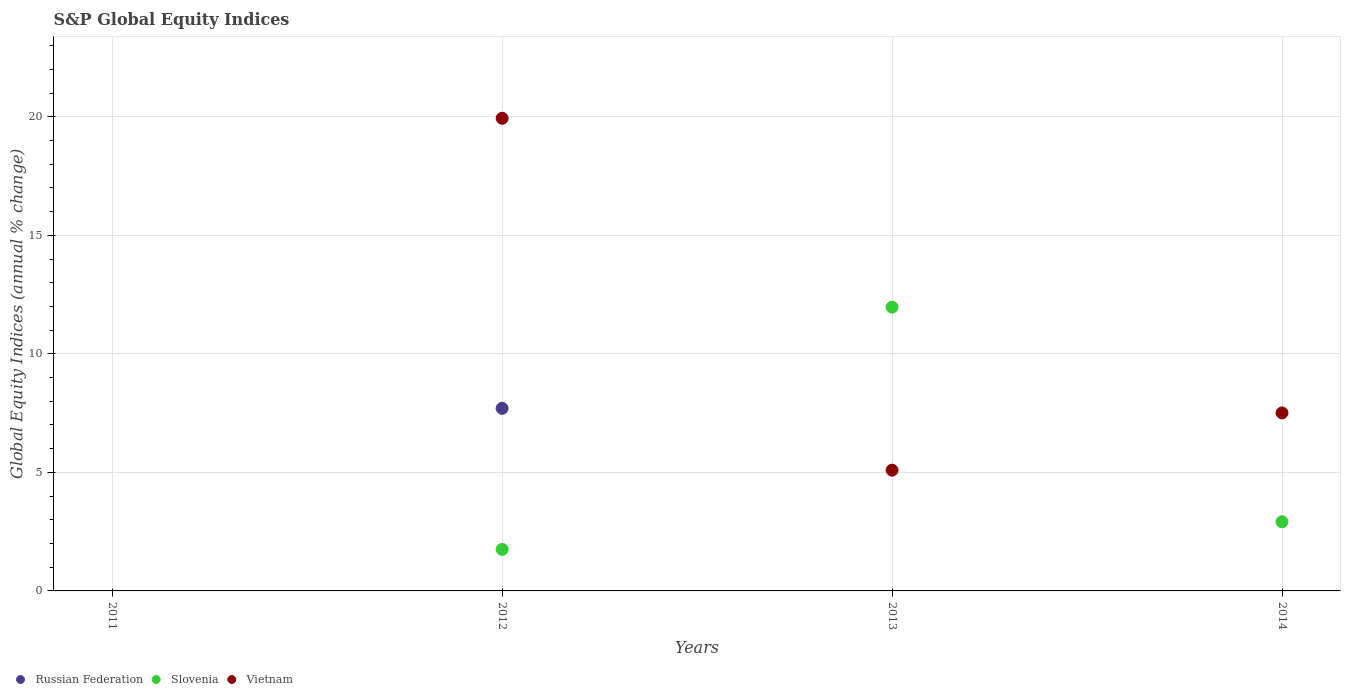Is the number of dotlines equal to the number of legend labels?
Ensure brevity in your answer.  No. What is the global equity indices in Vietnam in 2012?
Your answer should be very brief. 19.94. Across all years, what is the maximum global equity indices in Vietnam?
Your answer should be very brief. 19.94. Across all years, what is the minimum global equity indices in Slovenia?
Your response must be concise. 0. In which year was the global equity indices in Slovenia maximum?
Offer a very short reply. 2013. What is the total global equity indices in Vietnam in the graph?
Ensure brevity in your answer.  32.54. What is the difference between the global equity indices in Vietnam in 2013 and that in 2014?
Offer a very short reply. -2.42. What is the difference between the global equity indices in Slovenia in 2011 and the global equity indices in Vietnam in 2012?
Your answer should be compact. -19.94. What is the average global equity indices in Vietnam per year?
Keep it short and to the point. 8.14. In the year 2013, what is the difference between the global equity indices in Vietnam and global equity indices in Slovenia?
Provide a short and direct response. -6.88. In how many years, is the global equity indices in Russian Federation greater than 7 %?
Your answer should be compact. 1. What is the ratio of the global equity indices in Slovenia in 2012 to that in 2014?
Your response must be concise. 0.6. What is the difference between the highest and the second highest global equity indices in Slovenia?
Make the answer very short. 9.05. What is the difference between the highest and the lowest global equity indices in Russian Federation?
Keep it short and to the point. 7.7. In how many years, is the global equity indices in Vietnam greater than the average global equity indices in Vietnam taken over all years?
Your answer should be very brief. 1. Is the sum of the global equity indices in Vietnam in 2013 and 2014 greater than the maximum global equity indices in Slovenia across all years?
Ensure brevity in your answer.  Yes. Is it the case that in every year, the sum of the global equity indices in Slovenia and global equity indices in Russian Federation  is greater than the global equity indices in Vietnam?
Offer a very short reply. No. How many dotlines are there?
Make the answer very short. 3. What is the difference between two consecutive major ticks on the Y-axis?
Your response must be concise. 5. Are the values on the major ticks of Y-axis written in scientific E-notation?
Make the answer very short. No. Does the graph contain any zero values?
Your answer should be very brief. Yes. Where does the legend appear in the graph?
Keep it short and to the point. Bottom left. How many legend labels are there?
Ensure brevity in your answer.  3. What is the title of the graph?
Give a very brief answer. S&P Global Equity Indices. What is the label or title of the Y-axis?
Your answer should be very brief. Global Equity Indices (annual % change). What is the Global Equity Indices (annual % change) of Vietnam in 2011?
Your response must be concise. 0. What is the Global Equity Indices (annual % change) in Russian Federation in 2012?
Offer a terse response. 7.7. What is the Global Equity Indices (annual % change) of Slovenia in 2012?
Your answer should be very brief. 1.75. What is the Global Equity Indices (annual % change) in Vietnam in 2012?
Ensure brevity in your answer.  19.94. What is the Global Equity Indices (annual % change) of Russian Federation in 2013?
Make the answer very short. 0. What is the Global Equity Indices (annual % change) in Slovenia in 2013?
Provide a succinct answer. 11.97. What is the Global Equity Indices (annual % change) of Vietnam in 2013?
Provide a succinct answer. 5.09. What is the Global Equity Indices (annual % change) of Slovenia in 2014?
Keep it short and to the point. 2.92. What is the Global Equity Indices (annual % change) of Vietnam in 2014?
Provide a succinct answer. 7.51. Across all years, what is the maximum Global Equity Indices (annual % change) of Russian Federation?
Provide a succinct answer. 7.7. Across all years, what is the maximum Global Equity Indices (annual % change) of Slovenia?
Keep it short and to the point. 11.97. Across all years, what is the maximum Global Equity Indices (annual % change) in Vietnam?
Your response must be concise. 19.94. What is the total Global Equity Indices (annual % change) in Russian Federation in the graph?
Make the answer very short. 7.7. What is the total Global Equity Indices (annual % change) in Slovenia in the graph?
Keep it short and to the point. 16.64. What is the total Global Equity Indices (annual % change) of Vietnam in the graph?
Give a very brief answer. 32.54. What is the difference between the Global Equity Indices (annual % change) in Slovenia in 2012 and that in 2013?
Provide a short and direct response. -10.22. What is the difference between the Global Equity Indices (annual % change) in Vietnam in 2012 and that in 2013?
Your response must be concise. 14.85. What is the difference between the Global Equity Indices (annual % change) of Slovenia in 2012 and that in 2014?
Keep it short and to the point. -1.17. What is the difference between the Global Equity Indices (annual % change) of Vietnam in 2012 and that in 2014?
Offer a very short reply. 12.43. What is the difference between the Global Equity Indices (annual % change) in Slovenia in 2013 and that in 2014?
Give a very brief answer. 9.05. What is the difference between the Global Equity Indices (annual % change) of Vietnam in 2013 and that in 2014?
Your answer should be very brief. -2.42. What is the difference between the Global Equity Indices (annual % change) of Russian Federation in 2012 and the Global Equity Indices (annual % change) of Slovenia in 2013?
Keep it short and to the point. -4.27. What is the difference between the Global Equity Indices (annual % change) of Russian Federation in 2012 and the Global Equity Indices (annual % change) of Vietnam in 2013?
Give a very brief answer. 2.61. What is the difference between the Global Equity Indices (annual % change) in Slovenia in 2012 and the Global Equity Indices (annual % change) in Vietnam in 2013?
Provide a succinct answer. -3.34. What is the difference between the Global Equity Indices (annual % change) in Russian Federation in 2012 and the Global Equity Indices (annual % change) in Slovenia in 2014?
Your answer should be compact. 4.78. What is the difference between the Global Equity Indices (annual % change) in Russian Federation in 2012 and the Global Equity Indices (annual % change) in Vietnam in 2014?
Offer a very short reply. 0.19. What is the difference between the Global Equity Indices (annual % change) of Slovenia in 2012 and the Global Equity Indices (annual % change) of Vietnam in 2014?
Give a very brief answer. -5.76. What is the difference between the Global Equity Indices (annual % change) in Slovenia in 2013 and the Global Equity Indices (annual % change) in Vietnam in 2014?
Your answer should be compact. 4.46. What is the average Global Equity Indices (annual % change) in Russian Federation per year?
Offer a terse response. 1.93. What is the average Global Equity Indices (annual % change) in Slovenia per year?
Offer a terse response. 4.16. What is the average Global Equity Indices (annual % change) in Vietnam per year?
Give a very brief answer. 8.14. In the year 2012, what is the difference between the Global Equity Indices (annual % change) of Russian Federation and Global Equity Indices (annual % change) of Slovenia?
Your response must be concise. 5.95. In the year 2012, what is the difference between the Global Equity Indices (annual % change) in Russian Federation and Global Equity Indices (annual % change) in Vietnam?
Your answer should be compact. -12.24. In the year 2012, what is the difference between the Global Equity Indices (annual % change) in Slovenia and Global Equity Indices (annual % change) in Vietnam?
Ensure brevity in your answer.  -18.19. In the year 2013, what is the difference between the Global Equity Indices (annual % change) of Slovenia and Global Equity Indices (annual % change) of Vietnam?
Offer a terse response. 6.88. In the year 2014, what is the difference between the Global Equity Indices (annual % change) in Slovenia and Global Equity Indices (annual % change) in Vietnam?
Provide a succinct answer. -4.59. What is the ratio of the Global Equity Indices (annual % change) of Slovenia in 2012 to that in 2013?
Provide a succinct answer. 0.15. What is the ratio of the Global Equity Indices (annual % change) in Vietnam in 2012 to that in 2013?
Give a very brief answer. 3.91. What is the ratio of the Global Equity Indices (annual % change) in Vietnam in 2012 to that in 2014?
Make the answer very short. 2.66. What is the ratio of the Global Equity Indices (annual % change) of Slovenia in 2013 to that in 2014?
Keep it short and to the point. 4.1. What is the ratio of the Global Equity Indices (annual % change) of Vietnam in 2013 to that in 2014?
Ensure brevity in your answer.  0.68. What is the difference between the highest and the second highest Global Equity Indices (annual % change) of Slovenia?
Offer a very short reply. 9.05. What is the difference between the highest and the second highest Global Equity Indices (annual % change) in Vietnam?
Your answer should be very brief. 12.43. What is the difference between the highest and the lowest Global Equity Indices (annual % change) of Russian Federation?
Your answer should be compact. 7.7. What is the difference between the highest and the lowest Global Equity Indices (annual % change) in Slovenia?
Your answer should be very brief. 11.97. What is the difference between the highest and the lowest Global Equity Indices (annual % change) of Vietnam?
Offer a terse response. 19.94. 